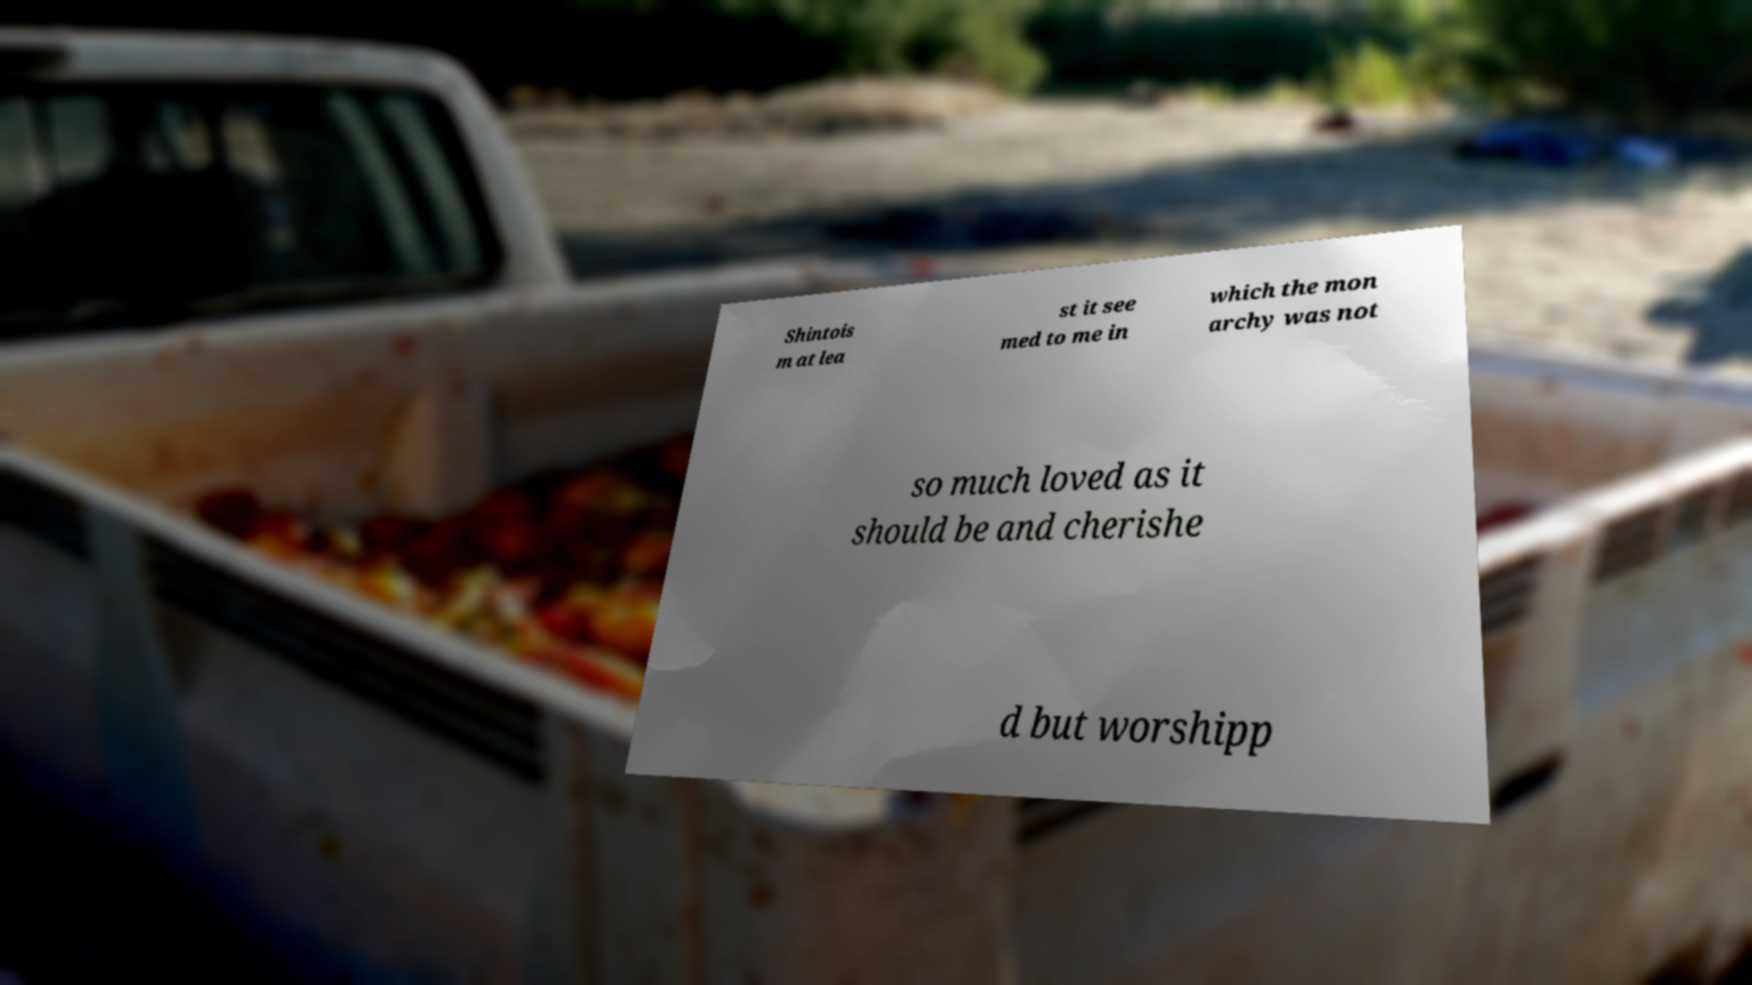Could you assist in decoding the text presented in this image and type it out clearly? Shintois m at lea st it see med to me in which the mon archy was not so much loved as it should be and cherishe d but worshipp 